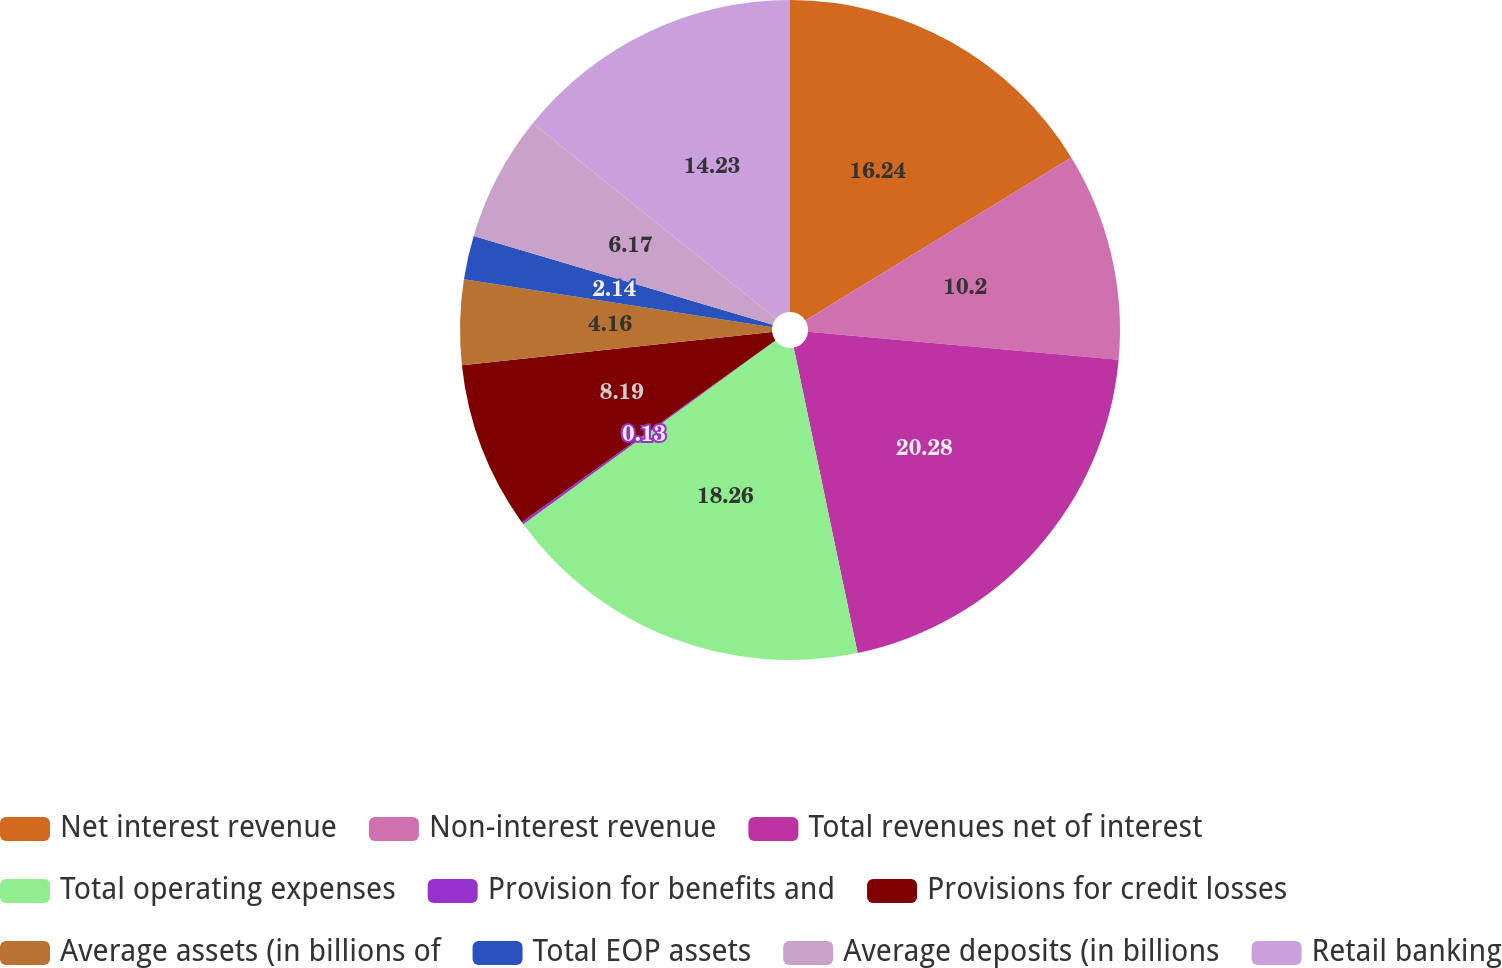Convert chart. <chart><loc_0><loc_0><loc_500><loc_500><pie_chart><fcel>Net interest revenue<fcel>Non-interest revenue<fcel>Total revenues net of interest<fcel>Total operating expenses<fcel>Provision for benefits and<fcel>Provisions for credit losses<fcel>Average assets (in billions of<fcel>Total EOP assets<fcel>Average deposits (in billions<fcel>Retail banking<nl><fcel>16.24%<fcel>10.2%<fcel>20.27%<fcel>18.26%<fcel>0.13%<fcel>8.19%<fcel>4.16%<fcel>2.14%<fcel>6.17%<fcel>14.23%<nl></chart> 